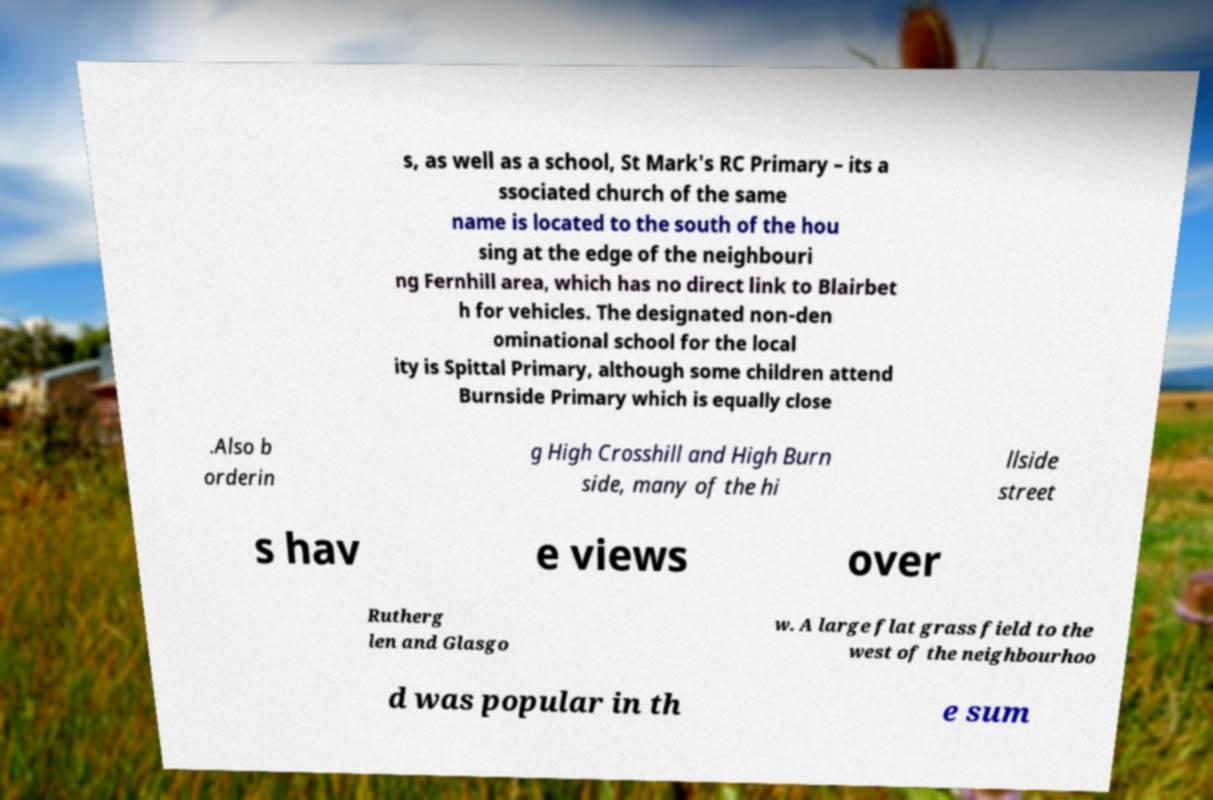What messages or text are displayed in this image? I need them in a readable, typed format. s, as well as a school, St Mark's RC Primary – its a ssociated church of the same name is located to the south of the hou sing at the edge of the neighbouri ng Fernhill area, which has no direct link to Blairbet h for vehicles. The designated non-den ominational school for the local ity is Spittal Primary, although some children attend Burnside Primary which is equally close .Also b orderin g High Crosshill and High Burn side, many of the hi llside street s hav e views over Rutherg len and Glasgo w. A large flat grass field to the west of the neighbourhoo d was popular in th e sum 